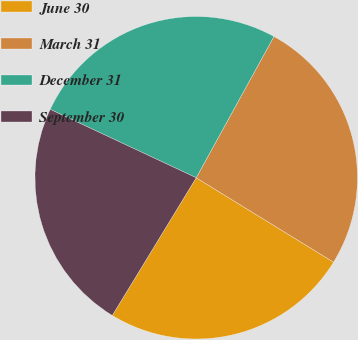Convert chart to OTSL. <chart><loc_0><loc_0><loc_500><loc_500><pie_chart><fcel>June 30<fcel>March 31<fcel>December 31<fcel>September 30<nl><fcel>24.94%<fcel>25.76%<fcel>26.04%<fcel>23.26%<nl></chart> 